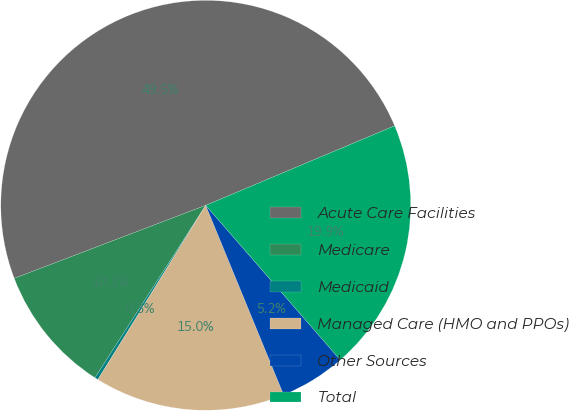Convert chart. <chart><loc_0><loc_0><loc_500><loc_500><pie_chart><fcel>Acute Care Facilities<fcel>Medicare<fcel>Medicaid<fcel>Managed Care (HMO and PPOs)<fcel>Other Sources<fcel>Total<nl><fcel>49.46%<fcel>10.11%<fcel>0.27%<fcel>15.03%<fcel>5.19%<fcel>19.95%<nl></chart> 